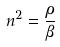Convert formula to latex. <formula><loc_0><loc_0><loc_500><loc_500>n ^ { 2 } = \frac { \rho } { \beta }</formula> 